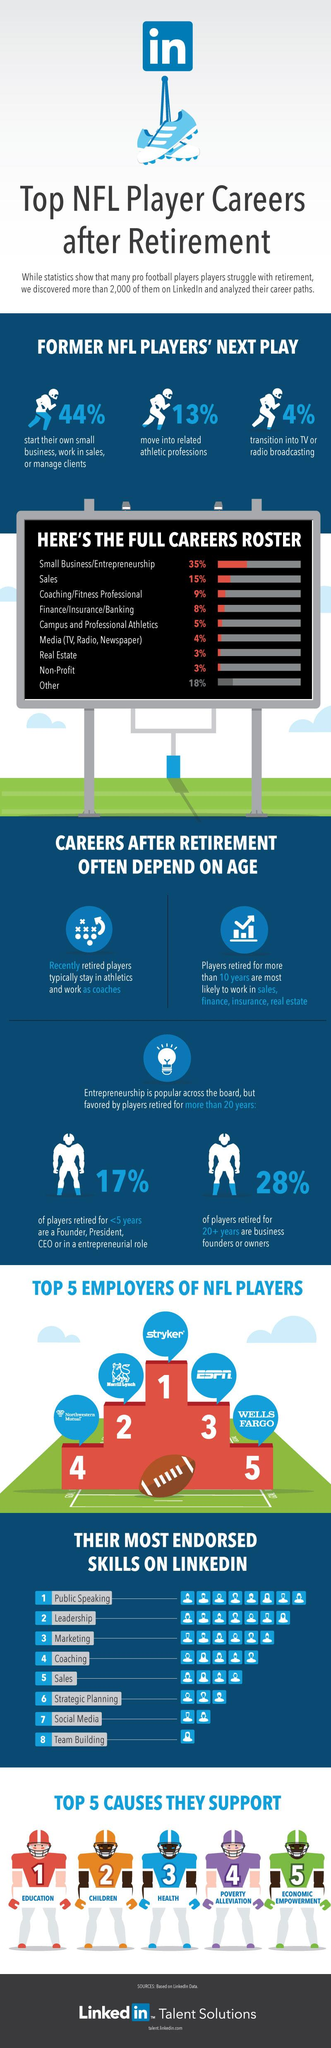Outline some significant characteristics in this image. According to a recent study, only 3% of former NFL players have moved into real estate professions. I declare that the most endorsed skill of former NFL players on LinkedIn is public speaking. According to a study, 28% of NFL players who retired for 20 or more years are business founders or owners. Stryker is the top employer on LinkedIn for former NFL players. According to a recent study, only 13% of former NFL players transition into related athletic professions after retiring from the sport. 